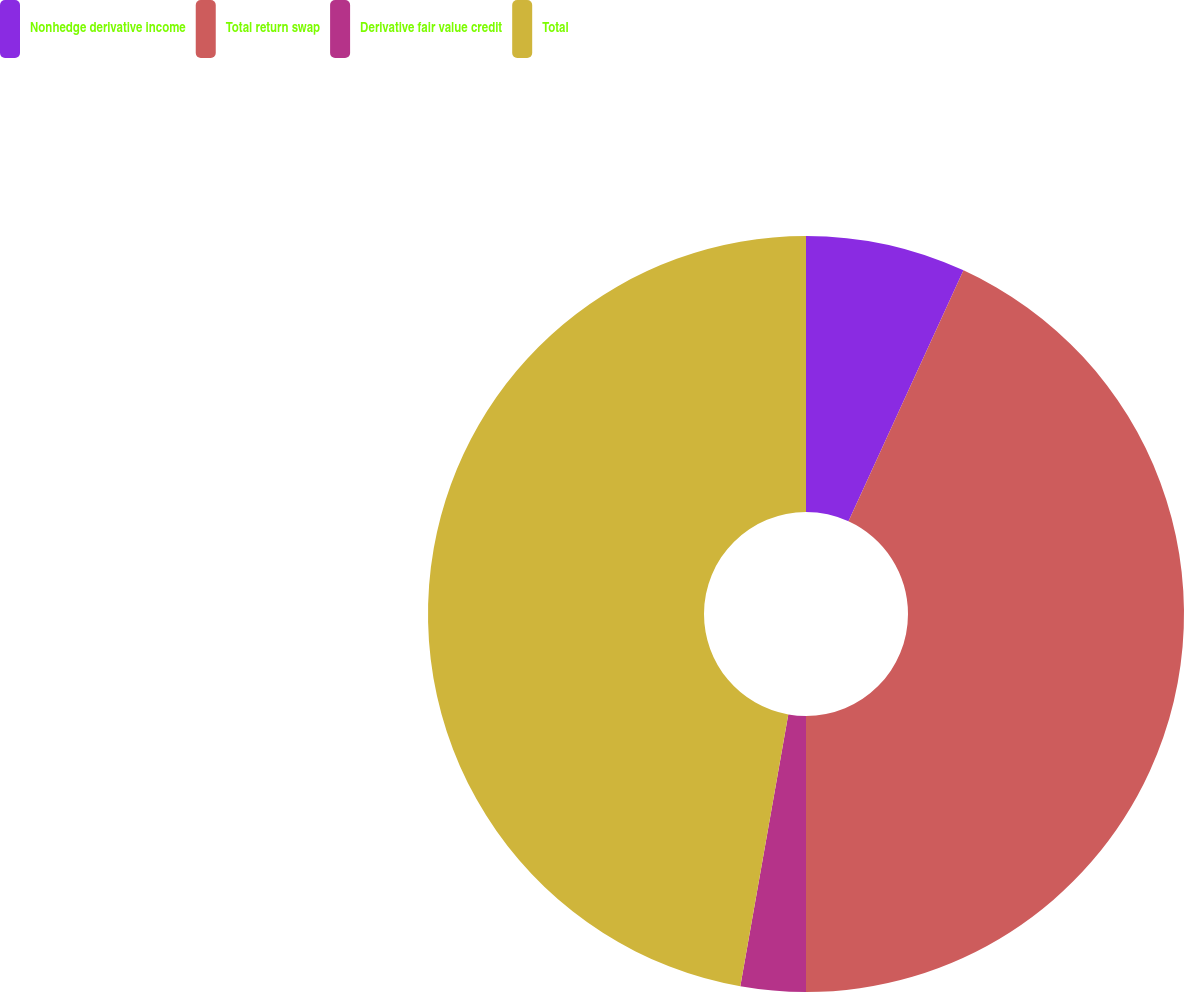<chart> <loc_0><loc_0><loc_500><loc_500><pie_chart><fcel>Nonhedge derivative income<fcel>Total return swap<fcel>Derivative fair value credit<fcel>Total<nl><fcel>6.84%<fcel>43.16%<fcel>2.78%<fcel>47.22%<nl></chart> 